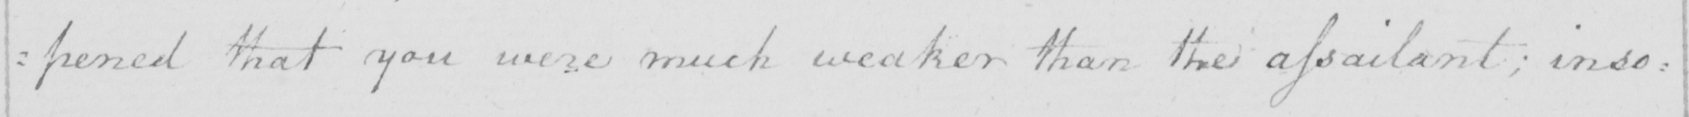What does this handwritten line say? :pened that you were much weaker than the assailant; inso= 